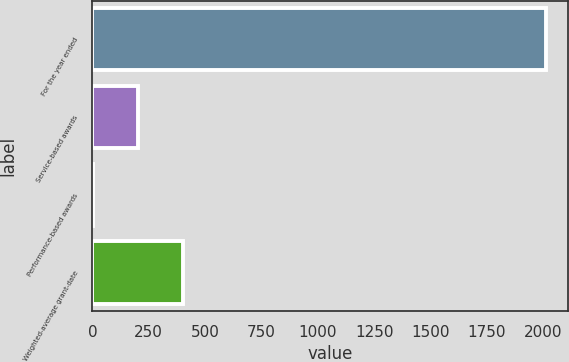Convert chart to OTSL. <chart><loc_0><loc_0><loc_500><loc_500><bar_chart><fcel>For the year ended<fcel>Service-based awards<fcel>Performance-based awards<fcel>Weighted-average grant-date<nl><fcel>2011<fcel>202.18<fcel>1.2<fcel>403.16<nl></chart> 